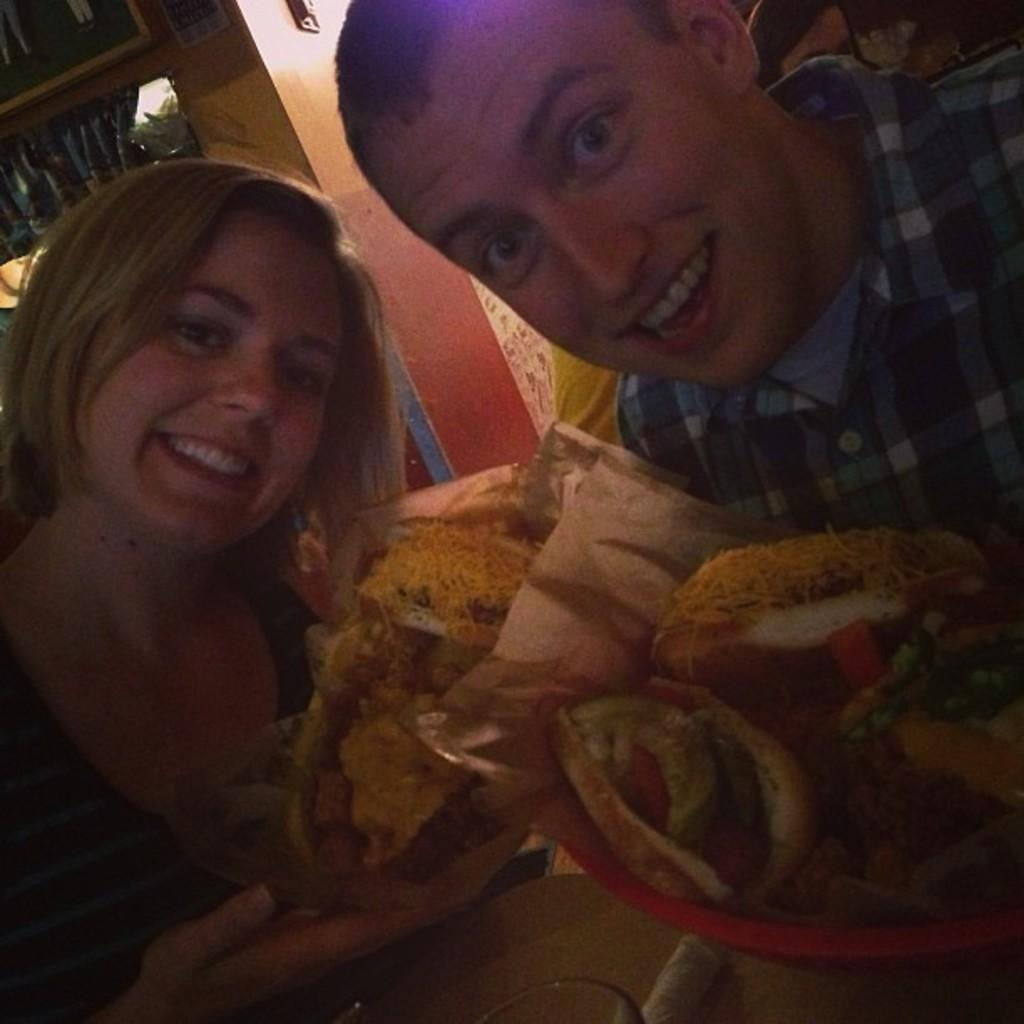How many people are in the image? There are two people in the image. Where are the two people located in the image? The two people are in the front of the image. What are the two people doing in the image? The two people are posing for a photo. What are the two people holding in their hands? The two people are holding food items in their hands. What type of poison is being used by the bears in the image? There are no bears present in the image, and therefore no poison can be observed. What decisions is the committee making in the image? There is no committee present in the image, and therefore no decisions can be made. 